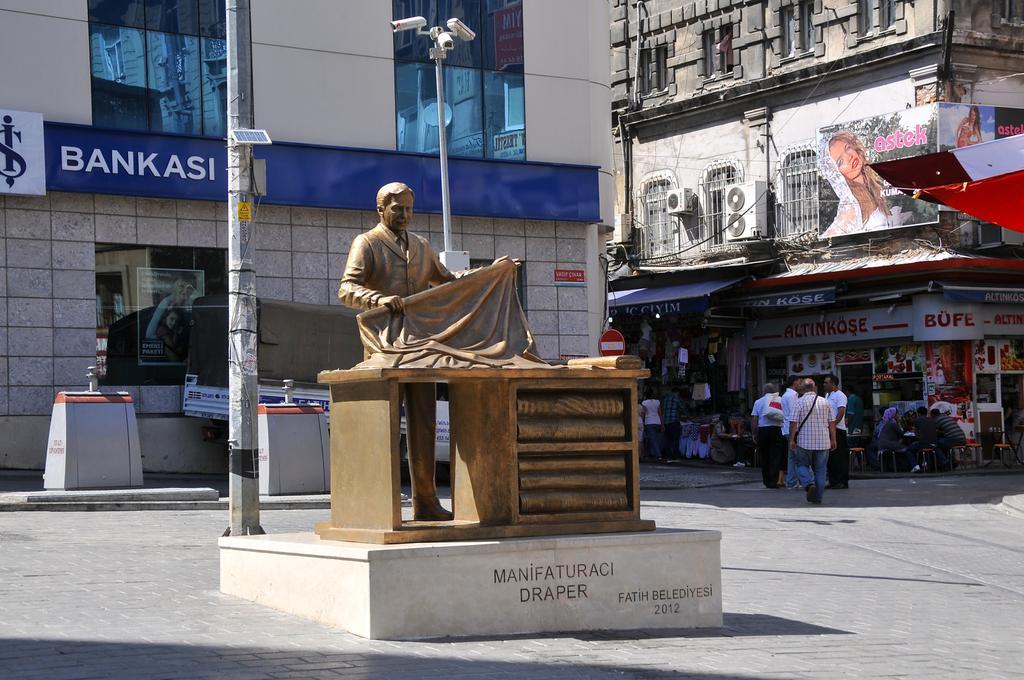Please provide a concise description of this image. In this picture we can see a statue of a person and a table on the path. Behind the statue there is a vehicle and poles with CCTV cameras. Behind the people there are buildings with name boards and hoards. We can see some people are standing, some people are walking on the path and some people are sitting on chairs. 